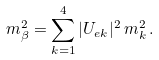<formula> <loc_0><loc_0><loc_500><loc_500>m _ { \beta } ^ { 2 } = \sum _ { k = 1 } ^ { 4 } | U _ { e k } | ^ { 2 } \, m _ { k } ^ { 2 } \, .</formula> 